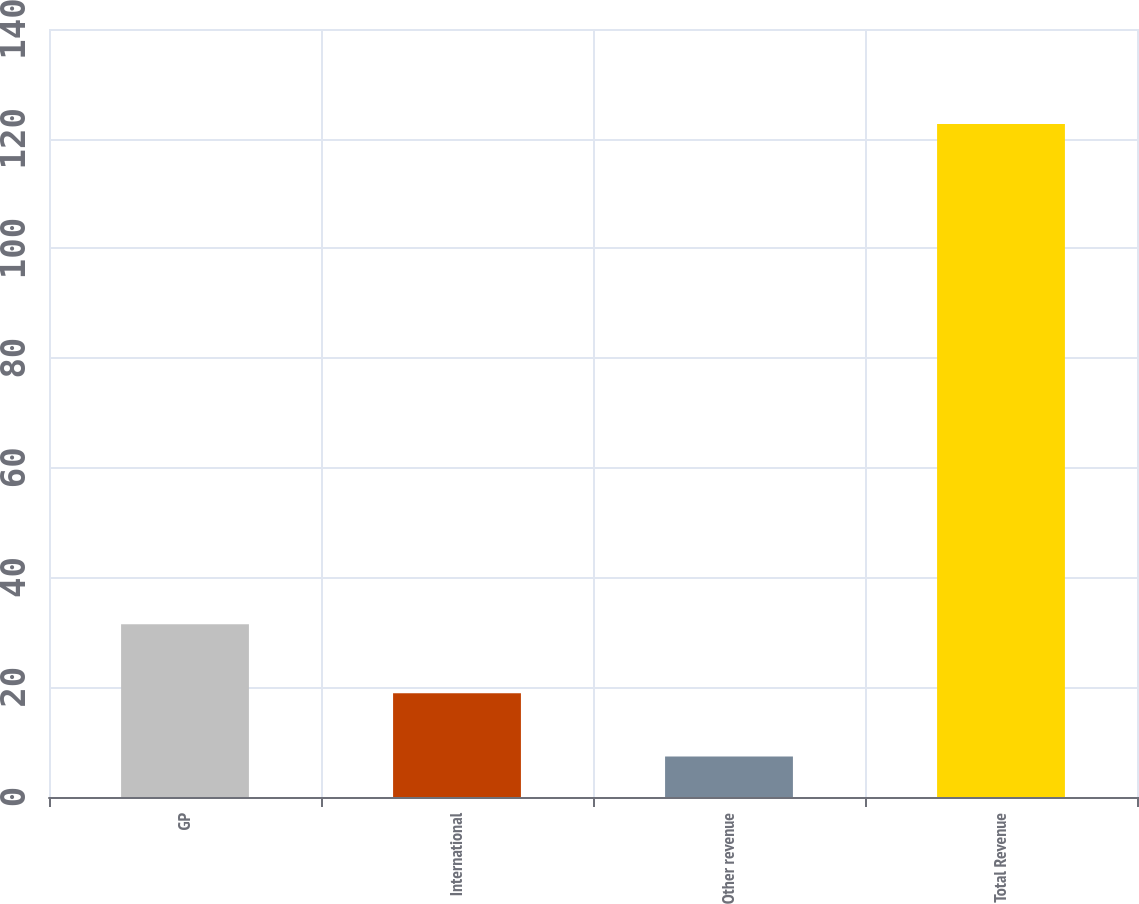<chart> <loc_0><loc_0><loc_500><loc_500><bar_chart><fcel>GP<fcel>International<fcel>Other revenue<fcel>Total Revenue<nl><fcel>31.5<fcel>18.93<fcel>7.4<fcel>122.7<nl></chart> 